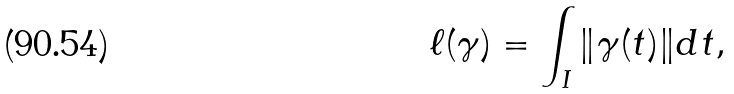<formula> <loc_0><loc_0><loc_500><loc_500>\ell ( \gamma ) = \int _ { I } \| \gamma ( t ) \| d t ,</formula> 